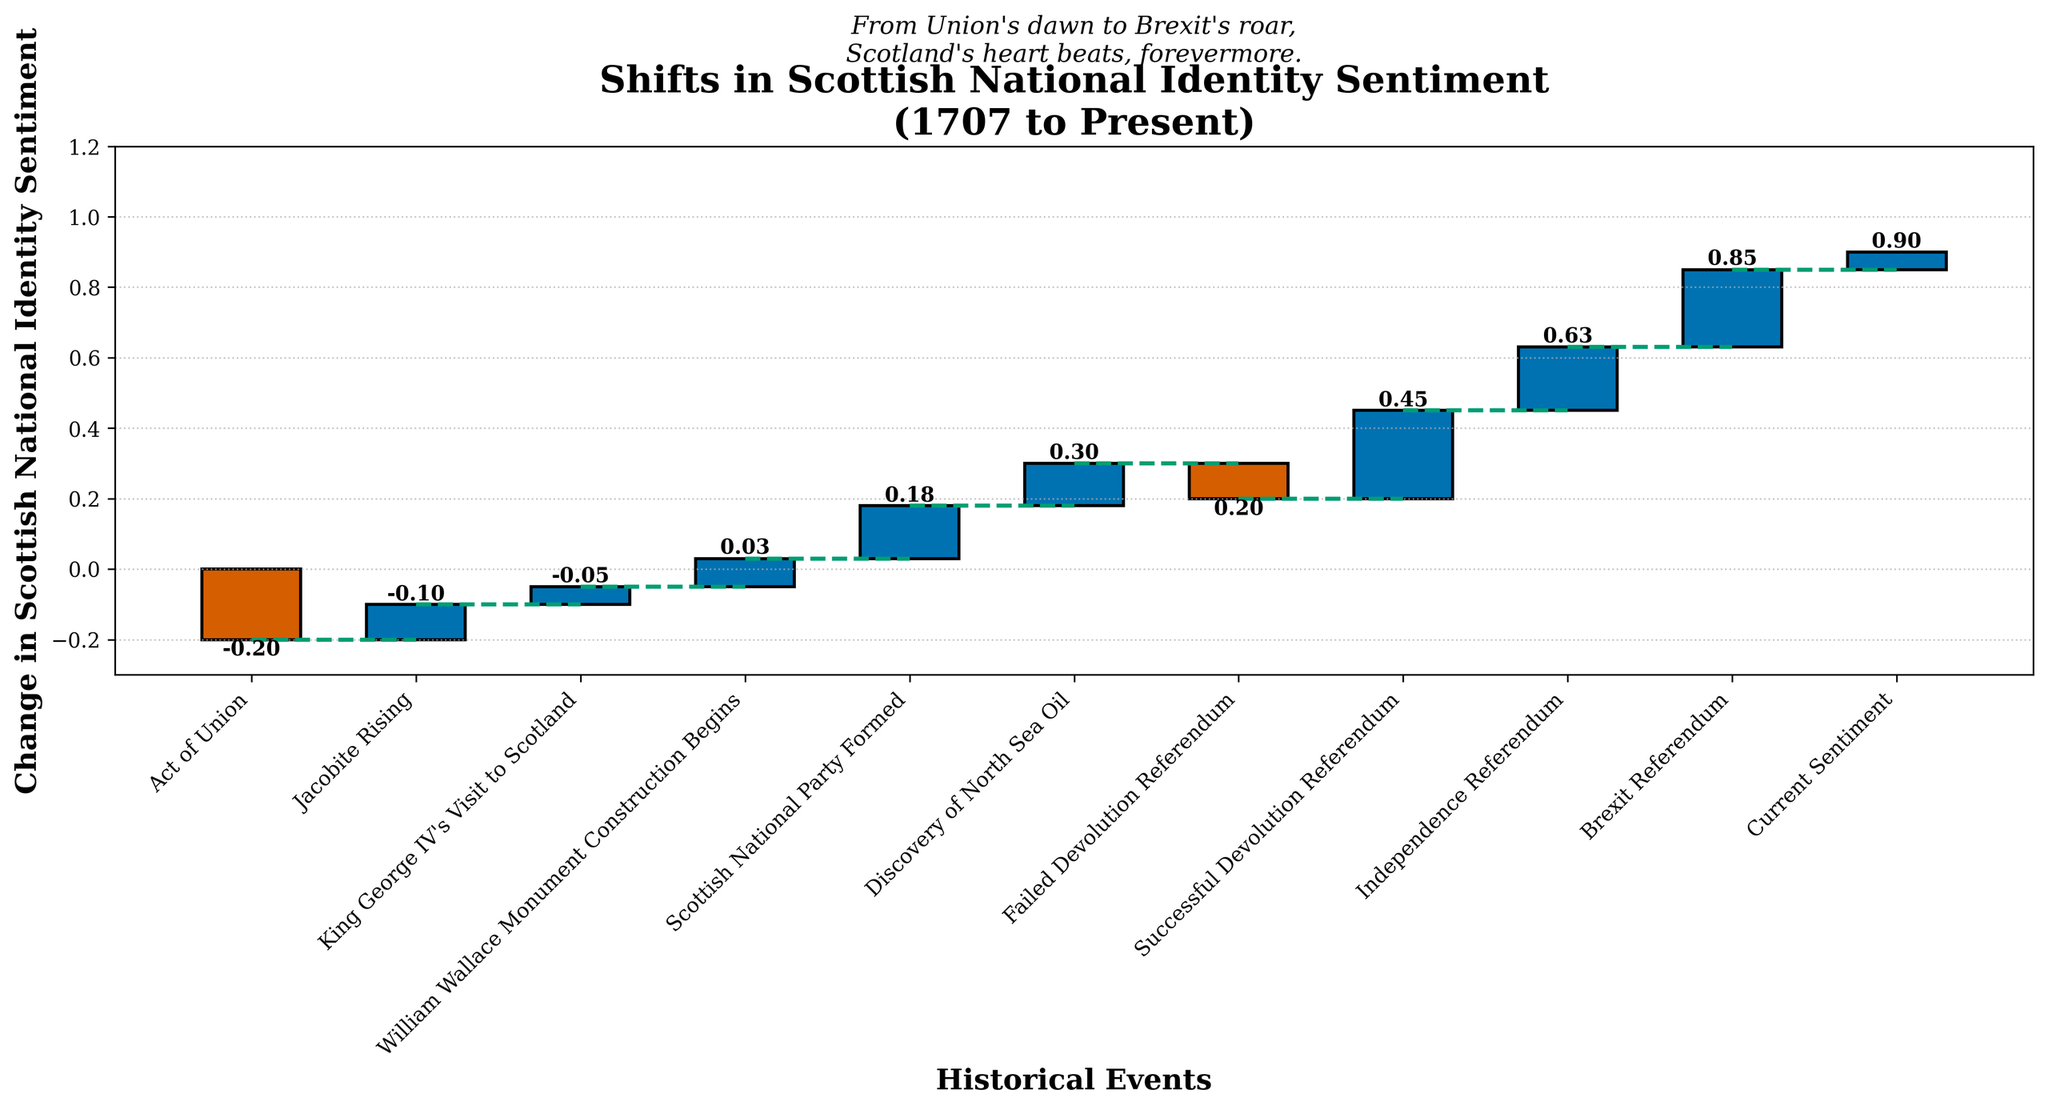What is the title of the chart? The title is written at the top of the chart. It reads "Shifts in Scottish National Identity Sentiment (1707 to Present)".
Answer: "Shifts in Scottish National Identity Sentiment (1707 to Present)" How many historical events are represented in the chart? Count the number of bars in the chart. There are 11 events from 1707 to 2023.
Answer: 11 Which event caused the largest positive shift in Scottish national identity sentiment? Identify the bar with the highest positive value and check the corresponding event. The Successful Devolution Referendum in 1997 caused the largest positive shift with a value of 0.25.
Answer: Successful Devolution Referendum 1997 What was the sentiment change after the Jacobite Rising of 1745? Locate the bar labeled "Jacobite Rising 1745" and note the change value. The change was 0.1.
Answer: 0.1 Does the final sentiment in 2023 indicate a positive or negative sentiment compared to the starting point in 1707? Compare the starting cumulative sentiment at 1707 (0.0) to the cumulative sentiment in 2023. The cumulative sentiment in 2023 is positive at 0.9 indicating a more positive sentiment compared to 1707.
Answer: Positive Which period shows a net negative shift in sentiment from the chart? Identify the period where the cumulative sentiment decreases. The net negative shift happened between 1707 (Act of Union, -0.2) and 1979 (Failed Devolution Referendum, -0.1).
Answer: 1707 to 1979 By how much did the sentiment change because of Brexit Referendum? Look at the value of the bar labeled "Brexit Referendum 2016." The sentiment change was 0.22.
Answer: 0.22 What is the total cumulative change in Scottish national identity sentiment from 1707 to present? Calculate the sum of all changes listed in the chart across all events. The sum is (-0.2 + 0.1 + 0.05 + 0.08 + 0.15 + 0.12 - 0.1 + 0.25 + 0.18 + 0.22 + 0.05) which equals 0.9.
Answer: 0.9 How many events show a negative shift in sentiment? Count the bars on the chart that are below the initial baseline. There are 2 events with a negative shift: Act of Union -0.2 and Failed Devolution Referendum -0.1.
Answer: 2 From which event onwards does the chart start showing a cumulative positive sentiment consistently? Track the cumulative sentiment values starting from 1707 and find the first event where it moves into positive territory and remains there. This occurs starting from King George IV’s Visit to Scotland in 1822.
Answer: King George IV’s Visit to Scotland 1822 